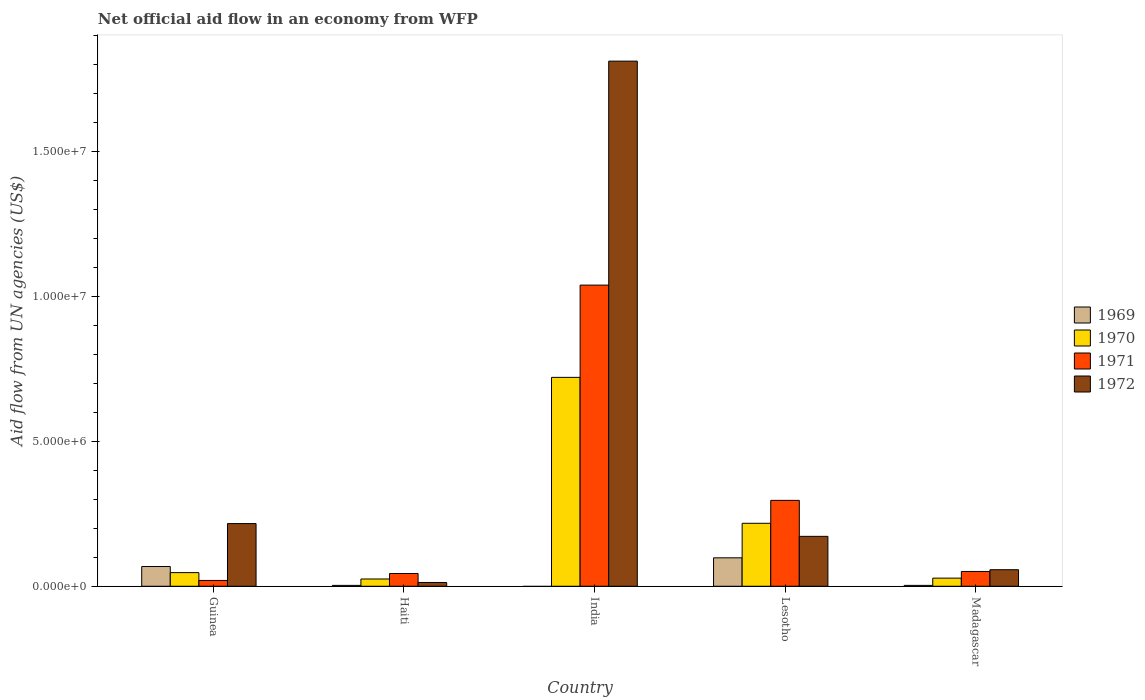How many different coloured bars are there?
Ensure brevity in your answer.  4. How many groups of bars are there?
Offer a terse response. 5. Are the number of bars per tick equal to the number of legend labels?
Provide a short and direct response. No. Are the number of bars on each tick of the X-axis equal?
Provide a short and direct response. No. How many bars are there on the 3rd tick from the right?
Offer a very short reply. 3. What is the label of the 5th group of bars from the left?
Offer a very short reply. Madagascar. In how many cases, is the number of bars for a given country not equal to the number of legend labels?
Keep it short and to the point. 1. Across all countries, what is the maximum net official aid flow in 1970?
Give a very brief answer. 7.20e+06. In which country was the net official aid flow in 1969 maximum?
Keep it short and to the point. Lesotho. What is the total net official aid flow in 1970 in the graph?
Provide a succinct answer. 1.04e+07. What is the difference between the net official aid flow in 1970 in Haiti and that in India?
Provide a succinct answer. -6.95e+06. What is the difference between the net official aid flow in 1970 in Madagascar and the net official aid flow in 1972 in Guinea?
Provide a succinct answer. -1.88e+06. What is the average net official aid flow in 1970 per country?
Your response must be concise. 2.07e+06. What is the difference between the net official aid flow of/in 1970 and net official aid flow of/in 1969 in Guinea?
Your answer should be compact. -2.10e+05. What is the ratio of the net official aid flow in 1970 in Haiti to that in India?
Offer a terse response. 0.03. What is the difference between the highest and the second highest net official aid flow in 1972?
Provide a short and direct response. 1.59e+07. What is the difference between the highest and the lowest net official aid flow in 1970?
Ensure brevity in your answer.  6.95e+06. In how many countries, is the net official aid flow in 1970 greater than the average net official aid flow in 1970 taken over all countries?
Provide a short and direct response. 2. Is the sum of the net official aid flow in 1970 in Guinea and Madagascar greater than the maximum net official aid flow in 1972 across all countries?
Keep it short and to the point. No. Are all the bars in the graph horizontal?
Your answer should be compact. No. How many countries are there in the graph?
Provide a succinct answer. 5. Does the graph contain any zero values?
Provide a succinct answer. Yes. Does the graph contain grids?
Give a very brief answer. No. Where does the legend appear in the graph?
Offer a very short reply. Center right. What is the title of the graph?
Make the answer very short. Net official aid flow in an economy from WFP. What is the label or title of the X-axis?
Your answer should be compact. Country. What is the label or title of the Y-axis?
Make the answer very short. Aid flow from UN agencies (US$). What is the Aid flow from UN agencies (US$) in 1969 in Guinea?
Make the answer very short. 6.80e+05. What is the Aid flow from UN agencies (US$) in 1970 in Guinea?
Ensure brevity in your answer.  4.70e+05. What is the Aid flow from UN agencies (US$) in 1972 in Guinea?
Give a very brief answer. 2.16e+06. What is the Aid flow from UN agencies (US$) in 1969 in Haiti?
Offer a very short reply. 3.00e+04. What is the Aid flow from UN agencies (US$) of 1970 in Haiti?
Provide a succinct answer. 2.50e+05. What is the Aid flow from UN agencies (US$) of 1970 in India?
Offer a very short reply. 7.20e+06. What is the Aid flow from UN agencies (US$) in 1971 in India?
Offer a very short reply. 1.04e+07. What is the Aid flow from UN agencies (US$) of 1972 in India?
Offer a very short reply. 1.81e+07. What is the Aid flow from UN agencies (US$) in 1969 in Lesotho?
Keep it short and to the point. 9.80e+05. What is the Aid flow from UN agencies (US$) of 1970 in Lesotho?
Your answer should be compact. 2.17e+06. What is the Aid flow from UN agencies (US$) in 1971 in Lesotho?
Your response must be concise. 2.96e+06. What is the Aid flow from UN agencies (US$) in 1972 in Lesotho?
Offer a terse response. 1.72e+06. What is the Aid flow from UN agencies (US$) in 1970 in Madagascar?
Your answer should be very brief. 2.80e+05. What is the Aid flow from UN agencies (US$) of 1971 in Madagascar?
Provide a short and direct response. 5.10e+05. What is the Aid flow from UN agencies (US$) in 1972 in Madagascar?
Provide a short and direct response. 5.70e+05. Across all countries, what is the maximum Aid flow from UN agencies (US$) of 1969?
Offer a terse response. 9.80e+05. Across all countries, what is the maximum Aid flow from UN agencies (US$) of 1970?
Your answer should be very brief. 7.20e+06. Across all countries, what is the maximum Aid flow from UN agencies (US$) in 1971?
Offer a terse response. 1.04e+07. Across all countries, what is the maximum Aid flow from UN agencies (US$) of 1972?
Offer a terse response. 1.81e+07. Across all countries, what is the minimum Aid flow from UN agencies (US$) in 1971?
Your response must be concise. 2.00e+05. What is the total Aid flow from UN agencies (US$) of 1969 in the graph?
Provide a succinct answer. 1.72e+06. What is the total Aid flow from UN agencies (US$) of 1970 in the graph?
Offer a terse response. 1.04e+07. What is the total Aid flow from UN agencies (US$) in 1971 in the graph?
Give a very brief answer. 1.45e+07. What is the total Aid flow from UN agencies (US$) of 1972 in the graph?
Ensure brevity in your answer.  2.27e+07. What is the difference between the Aid flow from UN agencies (US$) in 1969 in Guinea and that in Haiti?
Keep it short and to the point. 6.50e+05. What is the difference between the Aid flow from UN agencies (US$) in 1971 in Guinea and that in Haiti?
Ensure brevity in your answer.  -2.40e+05. What is the difference between the Aid flow from UN agencies (US$) of 1972 in Guinea and that in Haiti?
Your response must be concise. 2.03e+06. What is the difference between the Aid flow from UN agencies (US$) of 1970 in Guinea and that in India?
Make the answer very short. -6.73e+06. What is the difference between the Aid flow from UN agencies (US$) of 1971 in Guinea and that in India?
Give a very brief answer. -1.02e+07. What is the difference between the Aid flow from UN agencies (US$) of 1972 in Guinea and that in India?
Provide a succinct answer. -1.59e+07. What is the difference between the Aid flow from UN agencies (US$) of 1970 in Guinea and that in Lesotho?
Make the answer very short. -1.70e+06. What is the difference between the Aid flow from UN agencies (US$) in 1971 in Guinea and that in Lesotho?
Ensure brevity in your answer.  -2.76e+06. What is the difference between the Aid flow from UN agencies (US$) of 1969 in Guinea and that in Madagascar?
Offer a very short reply. 6.50e+05. What is the difference between the Aid flow from UN agencies (US$) of 1970 in Guinea and that in Madagascar?
Ensure brevity in your answer.  1.90e+05. What is the difference between the Aid flow from UN agencies (US$) in 1971 in Guinea and that in Madagascar?
Ensure brevity in your answer.  -3.10e+05. What is the difference between the Aid flow from UN agencies (US$) of 1972 in Guinea and that in Madagascar?
Your response must be concise. 1.59e+06. What is the difference between the Aid flow from UN agencies (US$) in 1970 in Haiti and that in India?
Your response must be concise. -6.95e+06. What is the difference between the Aid flow from UN agencies (US$) in 1971 in Haiti and that in India?
Provide a short and direct response. -9.94e+06. What is the difference between the Aid flow from UN agencies (US$) in 1972 in Haiti and that in India?
Provide a short and direct response. -1.80e+07. What is the difference between the Aid flow from UN agencies (US$) of 1969 in Haiti and that in Lesotho?
Your answer should be compact. -9.50e+05. What is the difference between the Aid flow from UN agencies (US$) in 1970 in Haiti and that in Lesotho?
Provide a succinct answer. -1.92e+06. What is the difference between the Aid flow from UN agencies (US$) in 1971 in Haiti and that in Lesotho?
Give a very brief answer. -2.52e+06. What is the difference between the Aid flow from UN agencies (US$) of 1972 in Haiti and that in Lesotho?
Your answer should be very brief. -1.59e+06. What is the difference between the Aid flow from UN agencies (US$) of 1972 in Haiti and that in Madagascar?
Make the answer very short. -4.40e+05. What is the difference between the Aid flow from UN agencies (US$) of 1970 in India and that in Lesotho?
Your response must be concise. 5.03e+06. What is the difference between the Aid flow from UN agencies (US$) in 1971 in India and that in Lesotho?
Ensure brevity in your answer.  7.42e+06. What is the difference between the Aid flow from UN agencies (US$) in 1972 in India and that in Lesotho?
Your answer should be compact. 1.64e+07. What is the difference between the Aid flow from UN agencies (US$) in 1970 in India and that in Madagascar?
Make the answer very short. 6.92e+06. What is the difference between the Aid flow from UN agencies (US$) in 1971 in India and that in Madagascar?
Keep it short and to the point. 9.87e+06. What is the difference between the Aid flow from UN agencies (US$) of 1972 in India and that in Madagascar?
Offer a terse response. 1.75e+07. What is the difference between the Aid flow from UN agencies (US$) in 1969 in Lesotho and that in Madagascar?
Make the answer very short. 9.50e+05. What is the difference between the Aid flow from UN agencies (US$) of 1970 in Lesotho and that in Madagascar?
Keep it short and to the point. 1.89e+06. What is the difference between the Aid flow from UN agencies (US$) of 1971 in Lesotho and that in Madagascar?
Provide a succinct answer. 2.45e+06. What is the difference between the Aid flow from UN agencies (US$) in 1972 in Lesotho and that in Madagascar?
Your answer should be compact. 1.15e+06. What is the difference between the Aid flow from UN agencies (US$) of 1969 in Guinea and the Aid flow from UN agencies (US$) of 1971 in Haiti?
Ensure brevity in your answer.  2.40e+05. What is the difference between the Aid flow from UN agencies (US$) in 1970 in Guinea and the Aid flow from UN agencies (US$) in 1972 in Haiti?
Offer a very short reply. 3.40e+05. What is the difference between the Aid flow from UN agencies (US$) of 1969 in Guinea and the Aid flow from UN agencies (US$) of 1970 in India?
Provide a succinct answer. -6.52e+06. What is the difference between the Aid flow from UN agencies (US$) in 1969 in Guinea and the Aid flow from UN agencies (US$) in 1971 in India?
Your response must be concise. -9.70e+06. What is the difference between the Aid flow from UN agencies (US$) in 1969 in Guinea and the Aid flow from UN agencies (US$) in 1972 in India?
Keep it short and to the point. -1.74e+07. What is the difference between the Aid flow from UN agencies (US$) of 1970 in Guinea and the Aid flow from UN agencies (US$) of 1971 in India?
Provide a short and direct response. -9.91e+06. What is the difference between the Aid flow from UN agencies (US$) in 1970 in Guinea and the Aid flow from UN agencies (US$) in 1972 in India?
Provide a succinct answer. -1.76e+07. What is the difference between the Aid flow from UN agencies (US$) of 1971 in Guinea and the Aid flow from UN agencies (US$) of 1972 in India?
Your answer should be compact. -1.79e+07. What is the difference between the Aid flow from UN agencies (US$) of 1969 in Guinea and the Aid flow from UN agencies (US$) of 1970 in Lesotho?
Make the answer very short. -1.49e+06. What is the difference between the Aid flow from UN agencies (US$) of 1969 in Guinea and the Aid flow from UN agencies (US$) of 1971 in Lesotho?
Your answer should be compact. -2.28e+06. What is the difference between the Aid flow from UN agencies (US$) of 1969 in Guinea and the Aid flow from UN agencies (US$) of 1972 in Lesotho?
Give a very brief answer. -1.04e+06. What is the difference between the Aid flow from UN agencies (US$) in 1970 in Guinea and the Aid flow from UN agencies (US$) in 1971 in Lesotho?
Provide a succinct answer. -2.49e+06. What is the difference between the Aid flow from UN agencies (US$) in 1970 in Guinea and the Aid flow from UN agencies (US$) in 1972 in Lesotho?
Your answer should be compact. -1.25e+06. What is the difference between the Aid flow from UN agencies (US$) of 1971 in Guinea and the Aid flow from UN agencies (US$) of 1972 in Lesotho?
Give a very brief answer. -1.52e+06. What is the difference between the Aid flow from UN agencies (US$) of 1970 in Guinea and the Aid flow from UN agencies (US$) of 1972 in Madagascar?
Your response must be concise. -1.00e+05. What is the difference between the Aid flow from UN agencies (US$) in 1971 in Guinea and the Aid flow from UN agencies (US$) in 1972 in Madagascar?
Your response must be concise. -3.70e+05. What is the difference between the Aid flow from UN agencies (US$) of 1969 in Haiti and the Aid flow from UN agencies (US$) of 1970 in India?
Give a very brief answer. -7.17e+06. What is the difference between the Aid flow from UN agencies (US$) in 1969 in Haiti and the Aid flow from UN agencies (US$) in 1971 in India?
Make the answer very short. -1.04e+07. What is the difference between the Aid flow from UN agencies (US$) in 1969 in Haiti and the Aid flow from UN agencies (US$) in 1972 in India?
Provide a succinct answer. -1.81e+07. What is the difference between the Aid flow from UN agencies (US$) of 1970 in Haiti and the Aid flow from UN agencies (US$) of 1971 in India?
Give a very brief answer. -1.01e+07. What is the difference between the Aid flow from UN agencies (US$) of 1970 in Haiti and the Aid flow from UN agencies (US$) of 1972 in India?
Your answer should be compact. -1.78e+07. What is the difference between the Aid flow from UN agencies (US$) of 1971 in Haiti and the Aid flow from UN agencies (US$) of 1972 in India?
Keep it short and to the point. -1.77e+07. What is the difference between the Aid flow from UN agencies (US$) in 1969 in Haiti and the Aid flow from UN agencies (US$) in 1970 in Lesotho?
Provide a succinct answer. -2.14e+06. What is the difference between the Aid flow from UN agencies (US$) in 1969 in Haiti and the Aid flow from UN agencies (US$) in 1971 in Lesotho?
Make the answer very short. -2.93e+06. What is the difference between the Aid flow from UN agencies (US$) of 1969 in Haiti and the Aid flow from UN agencies (US$) of 1972 in Lesotho?
Give a very brief answer. -1.69e+06. What is the difference between the Aid flow from UN agencies (US$) of 1970 in Haiti and the Aid flow from UN agencies (US$) of 1971 in Lesotho?
Offer a terse response. -2.71e+06. What is the difference between the Aid flow from UN agencies (US$) in 1970 in Haiti and the Aid flow from UN agencies (US$) in 1972 in Lesotho?
Keep it short and to the point. -1.47e+06. What is the difference between the Aid flow from UN agencies (US$) of 1971 in Haiti and the Aid flow from UN agencies (US$) of 1972 in Lesotho?
Provide a short and direct response. -1.28e+06. What is the difference between the Aid flow from UN agencies (US$) of 1969 in Haiti and the Aid flow from UN agencies (US$) of 1971 in Madagascar?
Provide a short and direct response. -4.80e+05. What is the difference between the Aid flow from UN agencies (US$) of 1969 in Haiti and the Aid flow from UN agencies (US$) of 1972 in Madagascar?
Your answer should be compact. -5.40e+05. What is the difference between the Aid flow from UN agencies (US$) of 1970 in Haiti and the Aid flow from UN agencies (US$) of 1972 in Madagascar?
Provide a short and direct response. -3.20e+05. What is the difference between the Aid flow from UN agencies (US$) of 1971 in Haiti and the Aid flow from UN agencies (US$) of 1972 in Madagascar?
Your answer should be very brief. -1.30e+05. What is the difference between the Aid flow from UN agencies (US$) of 1970 in India and the Aid flow from UN agencies (US$) of 1971 in Lesotho?
Make the answer very short. 4.24e+06. What is the difference between the Aid flow from UN agencies (US$) in 1970 in India and the Aid flow from UN agencies (US$) in 1972 in Lesotho?
Keep it short and to the point. 5.48e+06. What is the difference between the Aid flow from UN agencies (US$) in 1971 in India and the Aid flow from UN agencies (US$) in 1972 in Lesotho?
Offer a very short reply. 8.66e+06. What is the difference between the Aid flow from UN agencies (US$) of 1970 in India and the Aid flow from UN agencies (US$) of 1971 in Madagascar?
Ensure brevity in your answer.  6.69e+06. What is the difference between the Aid flow from UN agencies (US$) of 1970 in India and the Aid flow from UN agencies (US$) of 1972 in Madagascar?
Offer a very short reply. 6.63e+06. What is the difference between the Aid flow from UN agencies (US$) in 1971 in India and the Aid flow from UN agencies (US$) in 1972 in Madagascar?
Your response must be concise. 9.81e+06. What is the difference between the Aid flow from UN agencies (US$) of 1969 in Lesotho and the Aid flow from UN agencies (US$) of 1970 in Madagascar?
Your answer should be compact. 7.00e+05. What is the difference between the Aid flow from UN agencies (US$) in 1969 in Lesotho and the Aid flow from UN agencies (US$) in 1972 in Madagascar?
Ensure brevity in your answer.  4.10e+05. What is the difference between the Aid flow from UN agencies (US$) of 1970 in Lesotho and the Aid flow from UN agencies (US$) of 1971 in Madagascar?
Give a very brief answer. 1.66e+06. What is the difference between the Aid flow from UN agencies (US$) in 1970 in Lesotho and the Aid flow from UN agencies (US$) in 1972 in Madagascar?
Provide a short and direct response. 1.60e+06. What is the difference between the Aid flow from UN agencies (US$) of 1971 in Lesotho and the Aid flow from UN agencies (US$) of 1972 in Madagascar?
Your answer should be very brief. 2.39e+06. What is the average Aid flow from UN agencies (US$) of 1969 per country?
Ensure brevity in your answer.  3.44e+05. What is the average Aid flow from UN agencies (US$) of 1970 per country?
Your answer should be very brief. 2.07e+06. What is the average Aid flow from UN agencies (US$) in 1971 per country?
Your response must be concise. 2.90e+06. What is the average Aid flow from UN agencies (US$) in 1972 per country?
Provide a short and direct response. 4.54e+06. What is the difference between the Aid flow from UN agencies (US$) in 1969 and Aid flow from UN agencies (US$) in 1971 in Guinea?
Offer a very short reply. 4.80e+05. What is the difference between the Aid flow from UN agencies (US$) in 1969 and Aid flow from UN agencies (US$) in 1972 in Guinea?
Offer a terse response. -1.48e+06. What is the difference between the Aid flow from UN agencies (US$) in 1970 and Aid flow from UN agencies (US$) in 1972 in Guinea?
Make the answer very short. -1.69e+06. What is the difference between the Aid flow from UN agencies (US$) in 1971 and Aid flow from UN agencies (US$) in 1972 in Guinea?
Offer a very short reply. -1.96e+06. What is the difference between the Aid flow from UN agencies (US$) in 1969 and Aid flow from UN agencies (US$) in 1971 in Haiti?
Give a very brief answer. -4.10e+05. What is the difference between the Aid flow from UN agencies (US$) of 1969 and Aid flow from UN agencies (US$) of 1972 in Haiti?
Make the answer very short. -1.00e+05. What is the difference between the Aid flow from UN agencies (US$) in 1970 and Aid flow from UN agencies (US$) in 1972 in Haiti?
Give a very brief answer. 1.20e+05. What is the difference between the Aid flow from UN agencies (US$) of 1971 and Aid flow from UN agencies (US$) of 1972 in Haiti?
Offer a terse response. 3.10e+05. What is the difference between the Aid flow from UN agencies (US$) of 1970 and Aid flow from UN agencies (US$) of 1971 in India?
Keep it short and to the point. -3.18e+06. What is the difference between the Aid flow from UN agencies (US$) of 1970 and Aid flow from UN agencies (US$) of 1972 in India?
Offer a very short reply. -1.09e+07. What is the difference between the Aid flow from UN agencies (US$) in 1971 and Aid flow from UN agencies (US$) in 1972 in India?
Give a very brief answer. -7.72e+06. What is the difference between the Aid flow from UN agencies (US$) in 1969 and Aid flow from UN agencies (US$) in 1970 in Lesotho?
Make the answer very short. -1.19e+06. What is the difference between the Aid flow from UN agencies (US$) in 1969 and Aid flow from UN agencies (US$) in 1971 in Lesotho?
Give a very brief answer. -1.98e+06. What is the difference between the Aid flow from UN agencies (US$) of 1969 and Aid flow from UN agencies (US$) of 1972 in Lesotho?
Your answer should be compact. -7.40e+05. What is the difference between the Aid flow from UN agencies (US$) of 1970 and Aid flow from UN agencies (US$) of 1971 in Lesotho?
Your answer should be compact. -7.90e+05. What is the difference between the Aid flow from UN agencies (US$) of 1970 and Aid flow from UN agencies (US$) of 1972 in Lesotho?
Provide a short and direct response. 4.50e+05. What is the difference between the Aid flow from UN agencies (US$) of 1971 and Aid flow from UN agencies (US$) of 1972 in Lesotho?
Offer a very short reply. 1.24e+06. What is the difference between the Aid flow from UN agencies (US$) in 1969 and Aid flow from UN agencies (US$) in 1970 in Madagascar?
Your response must be concise. -2.50e+05. What is the difference between the Aid flow from UN agencies (US$) in 1969 and Aid flow from UN agencies (US$) in 1971 in Madagascar?
Your answer should be compact. -4.80e+05. What is the difference between the Aid flow from UN agencies (US$) of 1969 and Aid flow from UN agencies (US$) of 1972 in Madagascar?
Give a very brief answer. -5.40e+05. What is the difference between the Aid flow from UN agencies (US$) in 1970 and Aid flow from UN agencies (US$) in 1972 in Madagascar?
Offer a terse response. -2.90e+05. What is the difference between the Aid flow from UN agencies (US$) of 1971 and Aid flow from UN agencies (US$) of 1972 in Madagascar?
Your answer should be very brief. -6.00e+04. What is the ratio of the Aid flow from UN agencies (US$) in 1969 in Guinea to that in Haiti?
Provide a short and direct response. 22.67. What is the ratio of the Aid flow from UN agencies (US$) in 1970 in Guinea to that in Haiti?
Make the answer very short. 1.88. What is the ratio of the Aid flow from UN agencies (US$) in 1971 in Guinea to that in Haiti?
Your response must be concise. 0.45. What is the ratio of the Aid flow from UN agencies (US$) of 1972 in Guinea to that in Haiti?
Provide a short and direct response. 16.62. What is the ratio of the Aid flow from UN agencies (US$) of 1970 in Guinea to that in India?
Ensure brevity in your answer.  0.07. What is the ratio of the Aid flow from UN agencies (US$) of 1971 in Guinea to that in India?
Your answer should be compact. 0.02. What is the ratio of the Aid flow from UN agencies (US$) in 1972 in Guinea to that in India?
Ensure brevity in your answer.  0.12. What is the ratio of the Aid flow from UN agencies (US$) in 1969 in Guinea to that in Lesotho?
Provide a short and direct response. 0.69. What is the ratio of the Aid flow from UN agencies (US$) of 1970 in Guinea to that in Lesotho?
Keep it short and to the point. 0.22. What is the ratio of the Aid flow from UN agencies (US$) of 1971 in Guinea to that in Lesotho?
Offer a terse response. 0.07. What is the ratio of the Aid flow from UN agencies (US$) of 1972 in Guinea to that in Lesotho?
Your response must be concise. 1.26. What is the ratio of the Aid flow from UN agencies (US$) in 1969 in Guinea to that in Madagascar?
Give a very brief answer. 22.67. What is the ratio of the Aid flow from UN agencies (US$) of 1970 in Guinea to that in Madagascar?
Provide a short and direct response. 1.68. What is the ratio of the Aid flow from UN agencies (US$) in 1971 in Guinea to that in Madagascar?
Provide a short and direct response. 0.39. What is the ratio of the Aid flow from UN agencies (US$) in 1972 in Guinea to that in Madagascar?
Make the answer very short. 3.79. What is the ratio of the Aid flow from UN agencies (US$) of 1970 in Haiti to that in India?
Keep it short and to the point. 0.03. What is the ratio of the Aid flow from UN agencies (US$) of 1971 in Haiti to that in India?
Your answer should be compact. 0.04. What is the ratio of the Aid flow from UN agencies (US$) in 1972 in Haiti to that in India?
Your response must be concise. 0.01. What is the ratio of the Aid flow from UN agencies (US$) in 1969 in Haiti to that in Lesotho?
Make the answer very short. 0.03. What is the ratio of the Aid flow from UN agencies (US$) of 1970 in Haiti to that in Lesotho?
Offer a very short reply. 0.12. What is the ratio of the Aid flow from UN agencies (US$) in 1971 in Haiti to that in Lesotho?
Offer a very short reply. 0.15. What is the ratio of the Aid flow from UN agencies (US$) of 1972 in Haiti to that in Lesotho?
Your answer should be very brief. 0.08. What is the ratio of the Aid flow from UN agencies (US$) of 1969 in Haiti to that in Madagascar?
Provide a succinct answer. 1. What is the ratio of the Aid flow from UN agencies (US$) of 1970 in Haiti to that in Madagascar?
Your response must be concise. 0.89. What is the ratio of the Aid flow from UN agencies (US$) of 1971 in Haiti to that in Madagascar?
Make the answer very short. 0.86. What is the ratio of the Aid flow from UN agencies (US$) of 1972 in Haiti to that in Madagascar?
Give a very brief answer. 0.23. What is the ratio of the Aid flow from UN agencies (US$) of 1970 in India to that in Lesotho?
Make the answer very short. 3.32. What is the ratio of the Aid flow from UN agencies (US$) of 1971 in India to that in Lesotho?
Make the answer very short. 3.51. What is the ratio of the Aid flow from UN agencies (US$) of 1972 in India to that in Lesotho?
Give a very brief answer. 10.52. What is the ratio of the Aid flow from UN agencies (US$) in 1970 in India to that in Madagascar?
Offer a terse response. 25.71. What is the ratio of the Aid flow from UN agencies (US$) of 1971 in India to that in Madagascar?
Offer a very short reply. 20.35. What is the ratio of the Aid flow from UN agencies (US$) in 1972 in India to that in Madagascar?
Make the answer very short. 31.75. What is the ratio of the Aid flow from UN agencies (US$) in 1969 in Lesotho to that in Madagascar?
Keep it short and to the point. 32.67. What is the ratio of the Aid flow from UN agencies (US$) in 1970 in Lesotho to that in Madagascar?
Your response must be concise. 7.75. What is the ratio of the Aid flow from UN agencies (US$) of 1971 in Lesotho to that in Madagascar?
Keep it short and to the point. 5.8. What is the ratio of the Aid flow from UN agencies (US$) of 1972 in Lesotho to that in Madagascar?
Provide a short and direct response. 3.02. What is the difference between the highest and the second highest Aid flow from UN agencies (US$) of 1969?
Provide a succinct answer. 3.00e+05. What is the difference between the highest and the second highest Aid flow from UN agencies (US$) in 1970?
Ensure brevity in your answer.  5.03e+06. What is the difference between the highest and the second highest Aid flow from UN agencies (US$) in 1971?
Offer a terse response. 7.42e+06. What is the difference between the highest and the second highest Aid flow from UN agencies (US$) in 1972?
Your answer should be very brief. 1.59e+07. What is the difference between the highest and the lowest Aid flow from UN agencies (US$) of 1969?
Your answer should be very brief. 9.80e+05. What is the difference between the highest and the lowest Aid flow from UN agencies (US$) of 1970?
Your answer should be very brief. 6.95e+06. What is the difference between the highest and the lowest Aid flow from UN agencies (US$) of 1971?
Ensure brevity in your answer.  1.02e+07. What is the difference between the highest and the lowest Aid flow from UN agencies (US$) in 1972?
Your answer should be compact. 1.80e+07. 